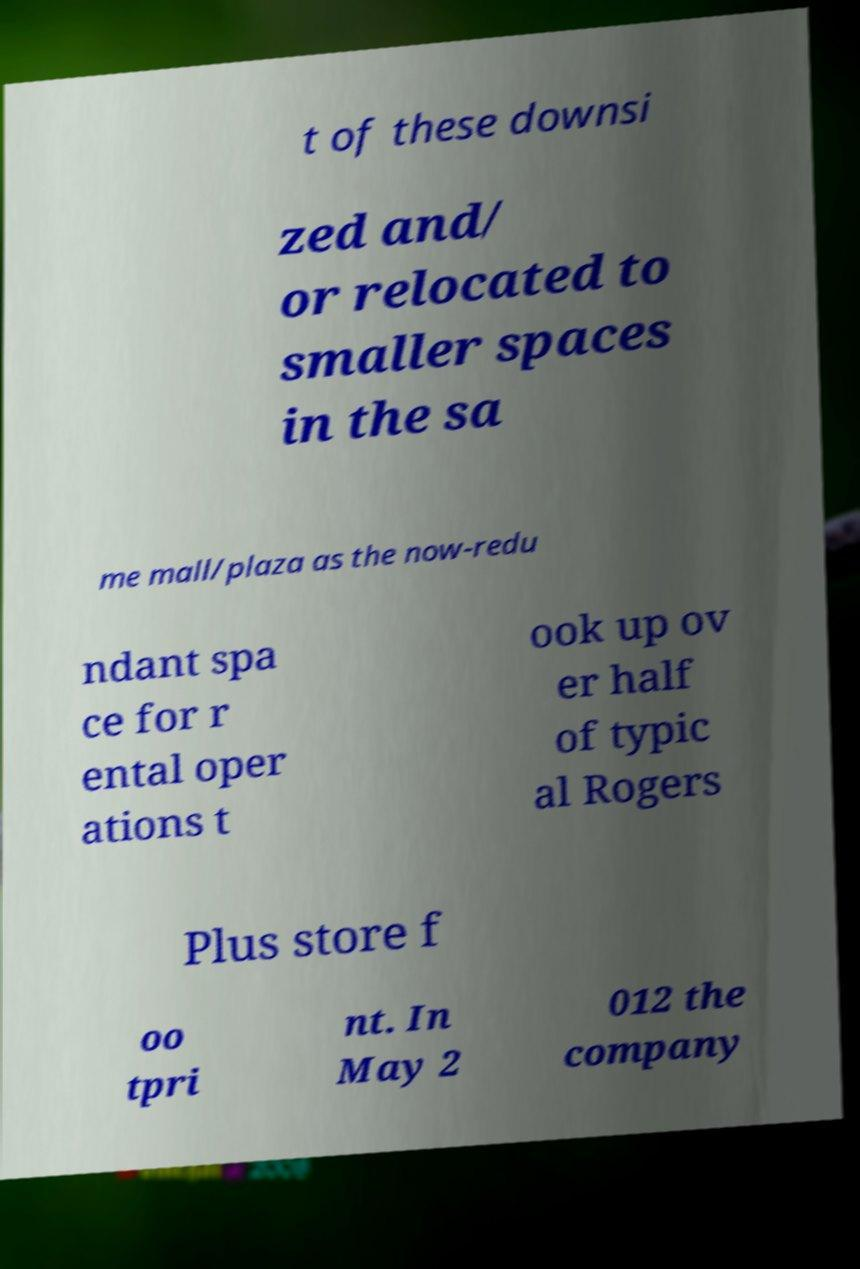What messages or text are displayed in this image? I need them in a readable, typed format. t of these downsi zed and/ or relocated to smaller spaces in the sa me mall/plaza as the now-redu ndant spa ce for r ental oper ations t ook up ov er half of typic al Rogers Plus store f oo tpri nt. In May 2 012 the company 